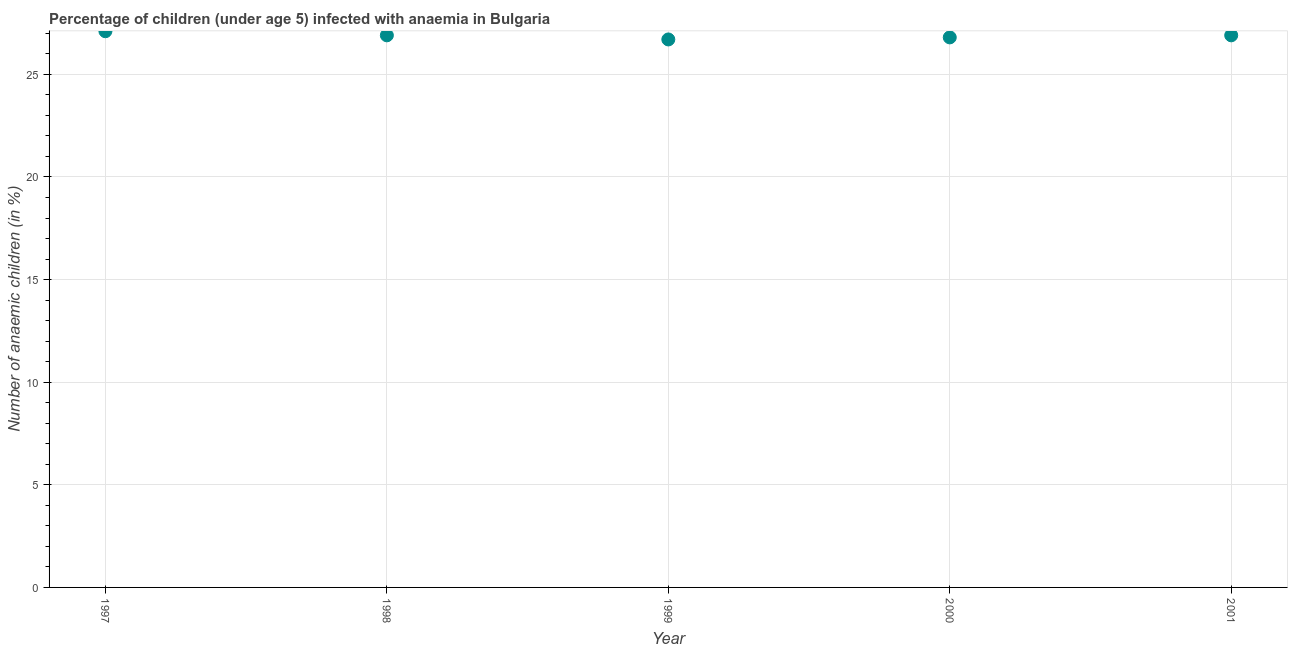What is the number of anaemic children in 2001?
Offer a very short reply. 26.9. Across all years, what is the maximum number of anaemic children?
Your response must be concise. 27.1. Across all years, what is the minimum number of anaemic children?
Offer a terse response. 26.7. In which year was the number of anaemic children maximum?
Give a very brief answer. 1997. What is the sum of the number of anaemic children?
Your answer should be very brief. 134.4. What is the difference between the number of anaemic children in 1998 and 1999?
Ensure brevity in your answer.  0.2. What is the average number of anaemic children per year?
Your response must be concise. 26.88. What is the median number of anaemic children?
Ensure brevity in your answer.  26.9. Do a majority of the years between 1998 and 1997 (inclusive) have number of anaemic children greater than 22 %?
Keep it short and to the point. No. What is the ratio of the number of anaemic children in 1997 to that in 1998?
Provide a succinct answer. 1.01. Is the difference between the number of anaemic children in 1997 and 1998 greater than the difference between any two years?
Give a very brief answer. No. What is the difference between the highest and the second highest number of anaemic children?
Offer a very short reply. 0.2. What is the difference between the highest and the lowest number of anaemic children?
Your answer should be compact. 0.4. How many dotlines are there?
Provide a short and direct response. 1. How many years are there in the graph?
Keep it short and to the point. 5. What is the difference between two consecutive major ticks on the Y-axis?
Keep it short and to the point. 5. Does the graph contain any zero values?
Ensure brevity in your answer.  No. Does the graph contain grids?
Keep it short and to the point. Yes. What is the title of the graph?
Provide a succinct answer. Percentage of children (under age 5) infected with anaemia in Bulgaria. What is the label or title of the Y-axis?
Provide a succinct answer. Number of anaemic children (in %). What is the Number of anaemic children (in %) in 1997?
Your answer should be very brief. 27.1. What is the Number of anaemic children (in %) in 1998?
Your answer should be very brief. 26.9. What is the Number of anaemic children (in %) in 1999?
Keep it short and to the point. 26.7. What is the Number of anaemic children (in %) in 2000?
Provide a short and direct response. 26.8. What is the Number of anaemic children (in %) in 2001?
Ensure brevity in your answer.  26.9. What is the difference between the Number of anaemic children (in %) in 1997 and 1998?
Offer a very short reply. 0.2. What is the difference between the Number of anaemic children (in %) in 1997 and 1999?
Your answer should be compact. 0.4. What is the difference between the Number of anaemic children (in %) in 1997 and 2000?
Offer a terse response. 0.3. What is the difference between the Number of anaemic children (in %) in 1998 and 1999?
Keep it short and to the point. 0.2. What is the difference between the Number of anaemic children (in %) in 1999 and 2000?
Your answer should be very brief. -0.1. What is the difference between the Number of anaemic children (in %) in 1999 and 2001?
Make the answer very short. -0.2. What is the ratio of the Number of anaemic children (in %) in 1997 to that in 1998?
Ensure brevity in your answer.  1.01. What is the ratio of the Number of anaemic children (in %) in 1997 to that in 1999?
Offer a very short reply. 1.01. What is the ratio of the Number of anaemic children (in %) in 1997 to that in 2001?
Make the answer very short. 1.01. What is the ratio of the Number of anaemic children (in %) in 1998 to that in 2000?
Provide a short and direct response. 1. What is the ratio of the Number of anaemic children (in %) in 1998 to that in 2001?
Offer a terse response. 1. What is the ratio of the Number of anaemic children (in %) in 1999 to that in 2000?
Provide a short and direct response. 1. What is the ratio of the Number of anaemic children (in %) in 1999 to that in 2001?
Provide a succinct answer. 0.99. 